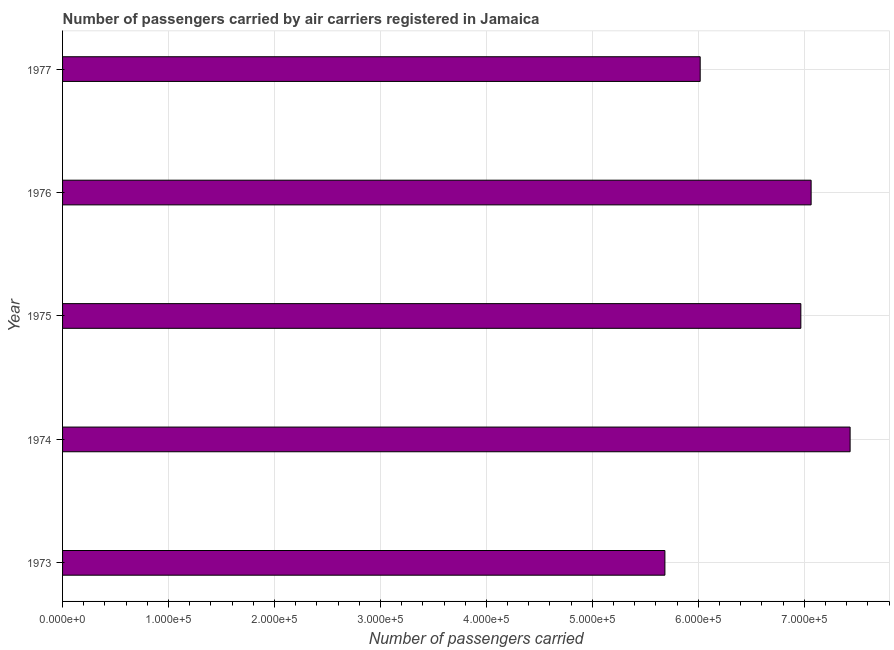Does the graph contain any zero values?
Provide a short and direct response. No. What is the title of the graph?
Your answer should be compact. Number of passengers carried by air carriers registered in Jamaica. What is the label or title of the X-axis?
Offer a very short reply. Number of passengers carried. What is the number of passengers carried in 1973?
Your response must be concise. 5.68e+05. Across all years, what is the maximum number of passengers carried?
Ensure brevity in your answer.  7.43e+05. Across all years, what is the minimum number of passengers carried?
Offer a very short reply. 5.68e+05. In which year was the number of passengers carried maximum?
Give a very brief answer. 1974. What is the sum of the number of passengers carried?
Provide a short and direct response. 3.32e+06. What is the difference between the number of passengers carried in 1973 and 1977?
Offer a very short reply. -3.33e+04. What is the average number of passengers carried per year?
Give a very brief answer. 6.63e+05. What is the median number of passengers carried?
Your answer should be compact. 6.97e+05. Do a majority of the years between 1977 and 1975 (inclusive) have number of passengers carried greater than 620000 ?
Your answer should be compact. Yes. What is the ratio of the number of passengers carried in 1973 to that in 1975?
Keep it short and to the point. 0.82. Is the number of passengers carried in 1975 less than that in 1977?
Your answer should be compact. No. What is the difference between the highest and the second highest number of passengers carried?
Your response must be concise. 3.68e+04. What is the difference between the highest and the lowest number of passengers carried?
Ensure brevity in your answer.  1.75e+05. In how many years, is the number of passengers carried greater than the average number of passengers carried taken over all years?
Provide a succinct answer. 3. How many years are there in the graph?
Keep it short and to the point. 5. Are the values on the major ticks of X-axis written in scientific E-notation?
Keep it short and to the point. Yes. What is the Number of passengers carried in 1973?
Your response must be concise. 5.68e+05. What is the Number of passengers carried of 1974?
Ensure brevity in your answer.  7.43e+05. What is the Number of passengers carried of 1975?
Offer a very short reply. 6.97e+05. What is the Number of passengers carried of 1976?
Your answer should be compact. 7.06e+05. What is the Number of passengers carried in 1977?
Give a very brief answer. 6.02e+05. What is the difference between the Number of passengers carried in 1973 and 1974?
Give a very brief answer. -1.75e+05. What is the difference between the Number of passengers carried in 1973 and 1975?
Keep it short and to the point. -1.28e+05. What is the difference between the Number of passengers carried in 1973 and 1976?
Give a very brief answer. -1.38e+05. What is the difference between the Number of passengers carried in 1973 and 1977?
Your response must be concise. -3.33e+04. What is the difference between the Number of passengers carried in 1974 and 1975?
Your response must be concise. 4.65e+04. What is the difference between the Number of passengers carried in 1974 and 1976?
Provide a short and direct response. 3.68e+04. What is the difference between the Number of passengers carried in 1974 and 1977?
Provide a short and direct response. 1.42e+05. What is the difference between the Number of passengers carried in 1975 and 1976?
Provide a short and direct response. -9700. What is the difference between the Number of passengers carried in 1975 and 1977?
Ensure brevity in your answer.  9.50e+04. What is the difference between the Number of passengers carried in 1976 and 1977?
Provide a succinct answer. 1.05e+05. What is the ratio of the Number of passengers carried in 1973 to that in 1974?
Ensure brevity in your answer.  0.77. What is the ratio of the Number of passengers carried in 1973 to that in 1975?
Your response must be concise. 0.82. What is the ratio of the Number of passengers carried in 1973 to that in 1976?
Your response must be concise. 0.81. What is the ratio of the Number of passengers carried in 1973 to that in 1977?
Ensure brevity in your answer.  0.94. What is the ratio of the Number of passengers carried in 1974 to that in 1975?
Your response must be concise. 1.07. What is the ratio of the Number of passengers carried in 1974 to that in 1976?
Your response must be concise. 1.05. What is the ratio of the Number of passengers carried in 1974 to that in 1977?
Provide a short and direct response. 1.24. What is the ratio of the Number of passengers carried in 1975 to that in 1976?
Provide a short and direct response. 0.99. What is the ratio of the Number of passengers carried in 1975 to that in 1977?
Ensure brevity in your answer.  1.16. What is the ratio of the Number of passengers carried in 1976 to that in 1977?
Keep it short and to the point. 1.17. 